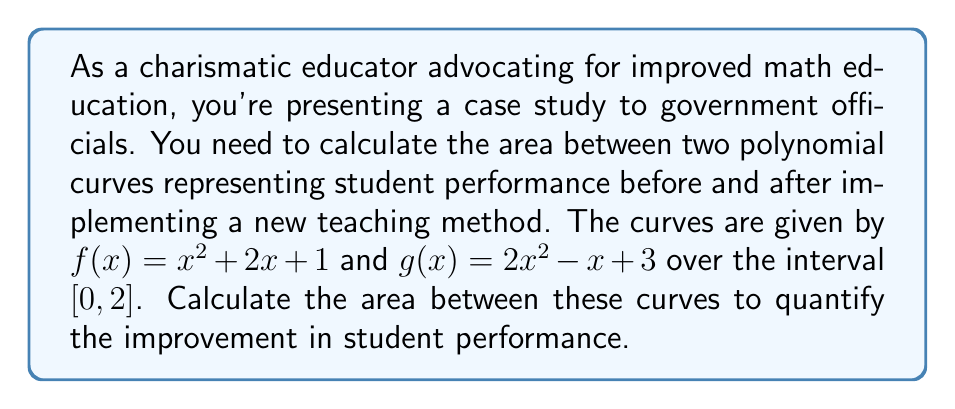Can you solve this math problem? To calculate the area between two polynomial curves, we follow these steps:

1) First, we need to determine which function is on top. We can do this by subtracting $f(x)$ from $g(x)$:

   $g(x) - f(x) = (2x^2 - x + 3) - (x^2 + 2x + 1) = x^2 - 3x + 2$

2) Now we need to find the points of intersection. We can do this by setting the difference equal to zero and solving:

   $x^2 - 3x + 2 = 0$
   $(x - 1)(x - 2) = 0$
   $x = 1$ or $x = 2$

3) We're given the interval $[0, 2]$, which includes both intersection points.

4) The area between the curves is given by the integral of the difference between the top function and the bottom function:

   $$A = \int_0^2 [g(x) - f(x)] dx = \int_0^2 (x^2 - 3x + 2) dx$$

5) Now we integrate:

   $$A = [\frac{1}{3}x^3 - \frac{3}{2}x^2 + 2x]_0^2$$

6) Evaluate at the limits:

   $$A = (\frac{1}{3}(2^3) - \frac{3}{2}(2^2) + 2(2)) - (\frac{1}{3}(0^3) - \frac{3}{2}(0^2) + 2(0))$$
   $$A = (\frac{8}{3} - 6 + 4) - (0)$$
   $$A = \frac{8}{3} - 2 = \frac{2}{3}$$

Therefore, the area between the curves is $\frac{2}{3}$ square units.
Answer: $\frac{2}{3}$ square units 